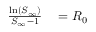Convert formula to latex. <formula><loc_0><loc_0><loc_500><loc_500>\begin{array} { r l } { \frac { \ln ( S _ { \infty } ) } { S _ { \infty } - 1 } } & = R _ { 0 } } \end{array}</formula> 